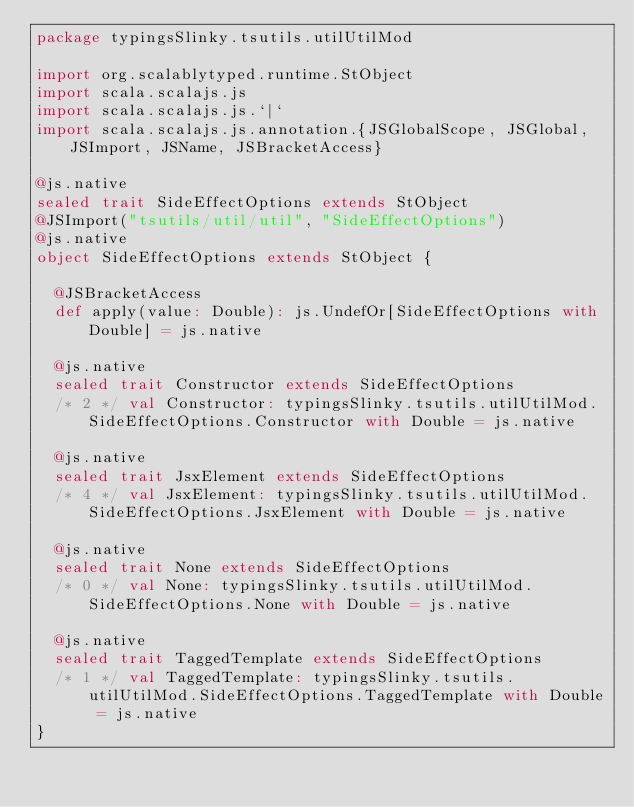<code> <loc_0><loc_0><loc_500><loc_500><_Scala_>package typingsSlinky.tsutils.utilUtilMod

import org.scalablytyped.runtime.StObject
import scala.scalajs.js
import scala.scalajs.js.`|`
import scala.scalajs.js.annotation.{JSGlobalScope, JSGlobal, JSImport, JSName, JSBracketAccess}

@js.native
sealed trait SideEffectOptions extends StObject
@JSImport("tsutils/util/util", "SideEffectOptions")
@js.native
object SideEffectOptions extends StObject {
  
  @JSBracketAccess
  def apply(value: Double): js.UndefOr[SideEffectOptions with Double] = js.native
  
  @js.native
  sealed trait Constructor extends SideEffectOptions
  /* 2 */ val Constructor: typingsSlinky.tsutils.utilUtilMod.SideEffectOptions.Constructor with Double = js.native
  
  @js.native
  sealed trait JsxElement extends SideEffectOptions
  /* 4 */ val JsxElement: typingsSlinky.tsutils.utilUtilMod.SideEffectOptions.JsxElement with Double = js.native
  
  @js.native
  sealed trait None extends SideEffectOptions
  /* 0 */ val None: typingsSlinky.tsutils.utilUtilMod.SideEffectOptions.None with Double = js.native
  
  @js.native
  sealed trait TaggedTemplate extends SideEffectOptions
  /* 1 */ val TaggedTemplate: typingsSlinky.tsutils.utilUtilMod.SideEffectOptions.TaggedTemplate with Double = js.native
}
</code> 